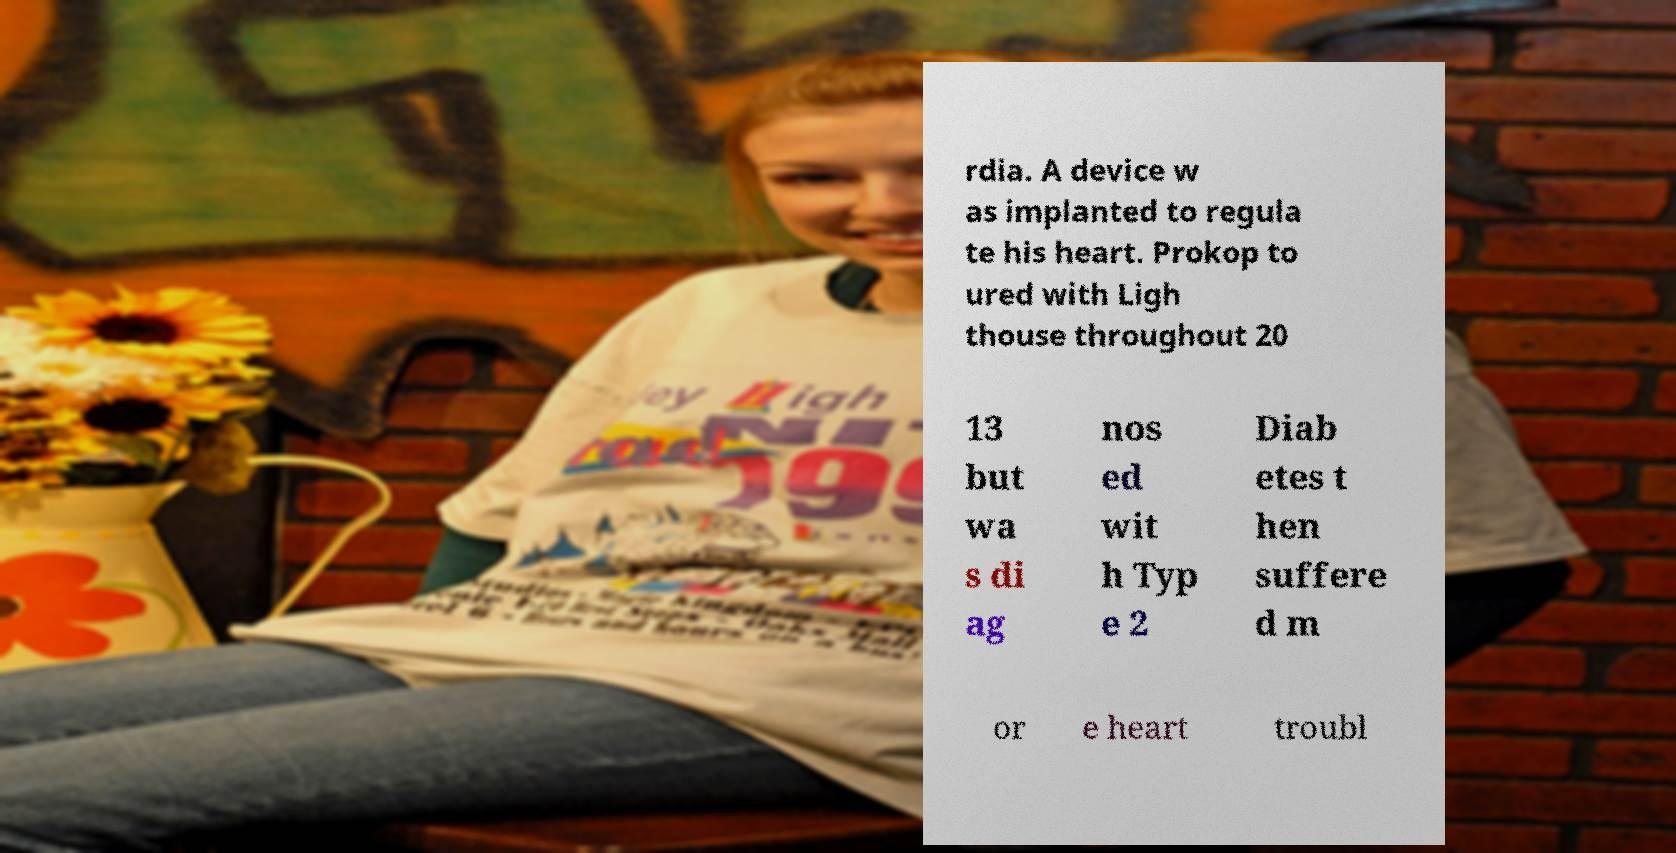What messages or text are displayed in this image? I need them in a readable, typed format. rdia. A device w as implanted to regula te his heart. Prokop to ured with Ligh thouse throughout 20 13 but wa s di ag nos ed wit h Typ e 2 Diab etes t hen suffere d m or e heart troubl 